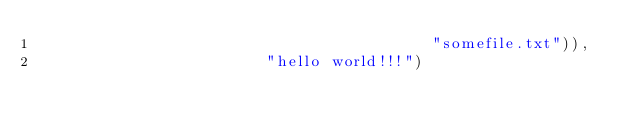Convert code to text. <code><loc_0><loc_0><loc_500><loc_500><_Python_>                                           "somefile.txt")),
                         "hello world!!!")</code> 